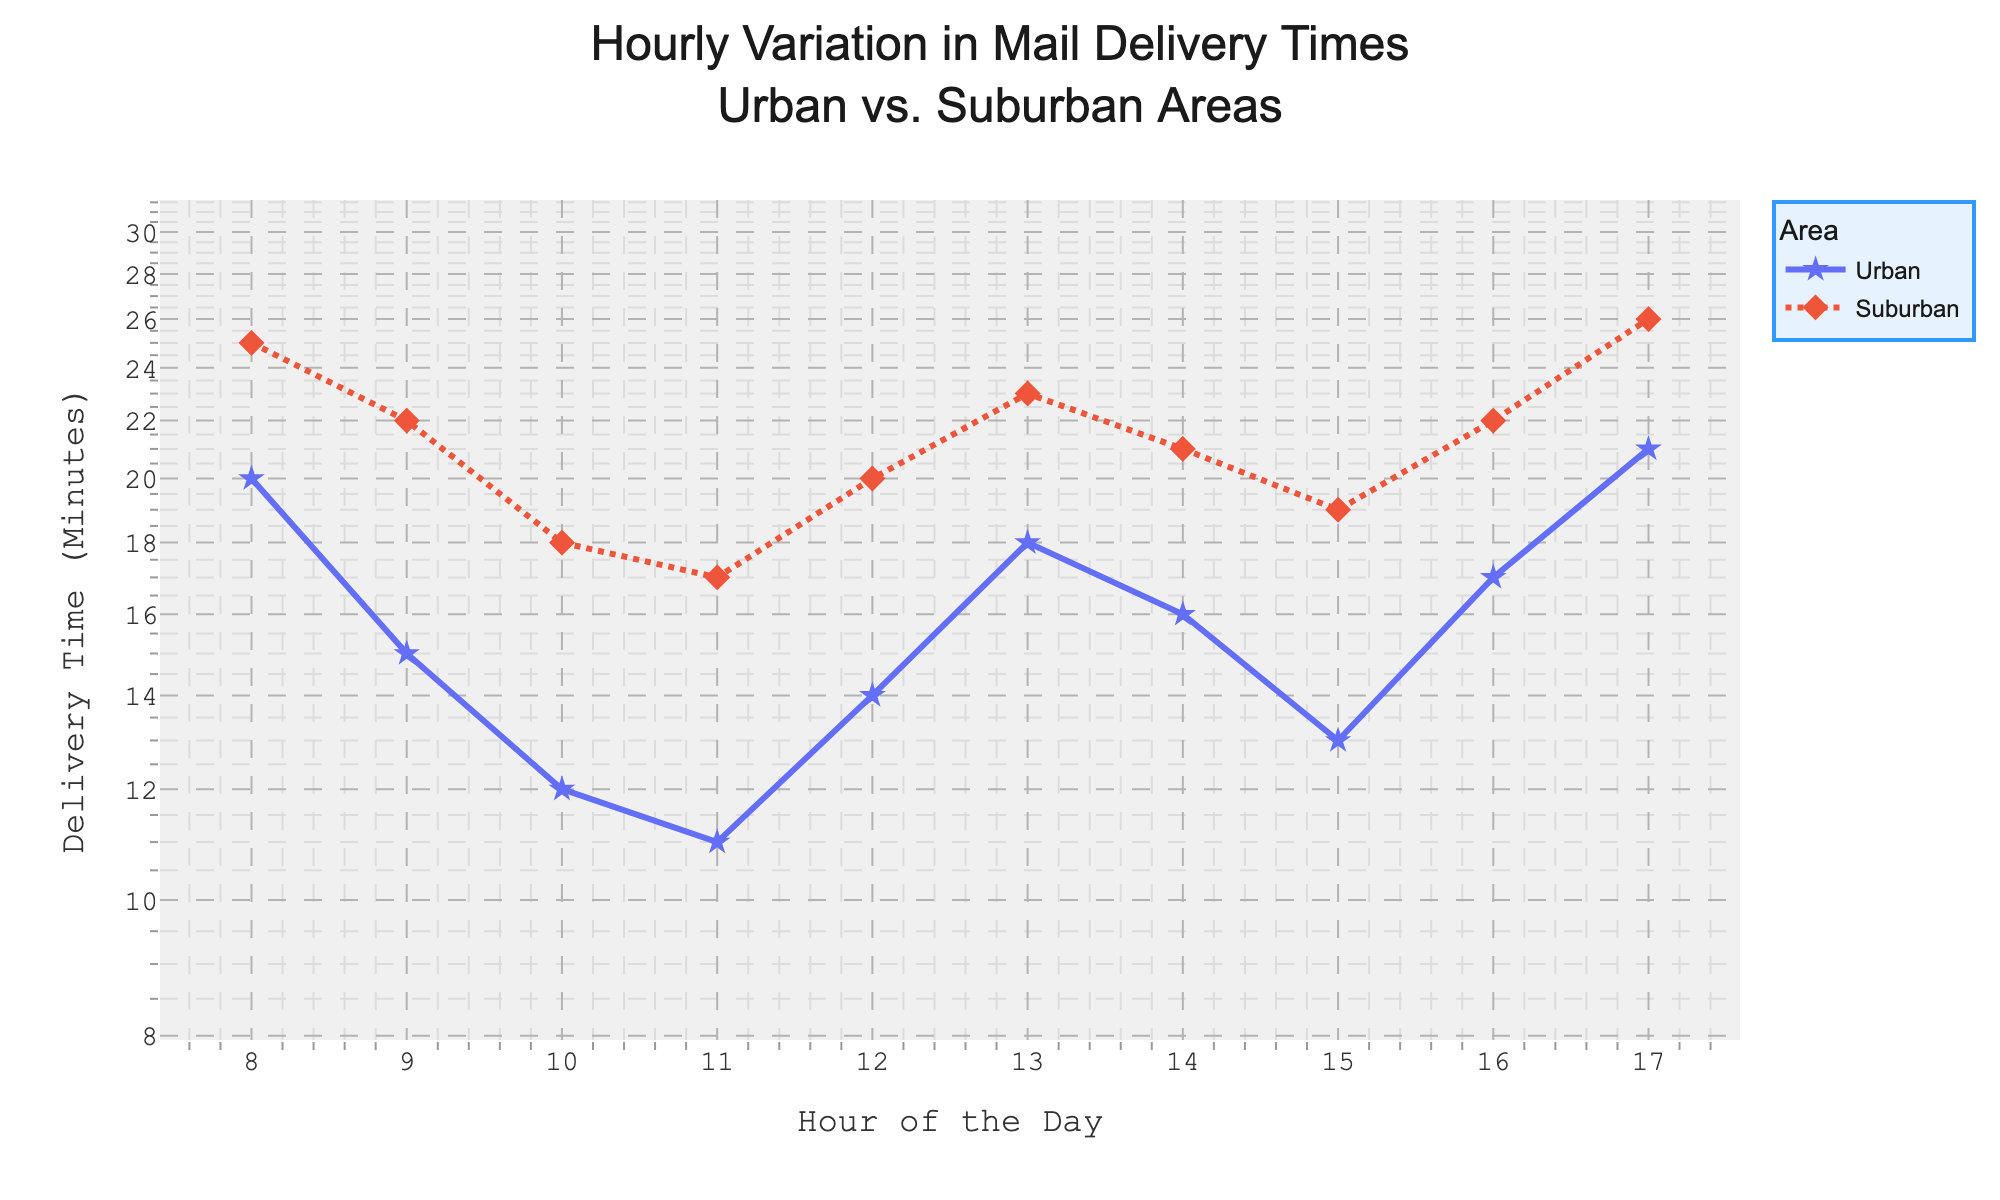What is the title of the plot? Look at the top center of the plot, where the title is usually placed.
Answer: Hourly Variation in Mail Delivery Times Urban vs. Suburban Areas How many different areas are represented in the plot, and what are they? In the legend or the lines on the plot, you can see the different areas represented.
Answer: 2, Urban and Suburban What color represents the Urban area? Check the legend or look at one of the two colored lines in the plot.
Answer: Blue At 10 AM, how long does it take to deliver mail in Suburban areas? Find the '10' on the x-axis, then look at the corresponding point on the line for Suburban areas (dashed line).
Answer: 18 minutes Which area has a higher delivery time at 12 PM? Compare the y-values at 12 PM for both Urban and Suburban areas on the plot.
Answer: Suburban What is the general trend for mail delivery times in both areas as the day progresses? Observe the pattern of the lines as they move from morning to evening.
Answer: Both areas tend to have a lower delivery time in the late morning and higher delivery time in the early morning and late afternoon Calculate the average delivery time at 8 AM for Urban and Suburban areas combined. Add the delivery times for both areas at 8 AM and divide by 2. The times are Urban: 20 minutes, Suburban: 25 minutes. Average = (20 + 25) / 2 = 22.5 minutes.
Answer: 22.5 minutes What hour shows the smallest difference in delivery times between Urban and Suburban areas? Check each hour and find where the difference between the two y-values is the smallest.
Answer: 10 AM By what factor does the delivery time at 8 AM in Suburban areas exceed that in Urban areas? Divide the Suburban delivery time by the Urban delivery time at 8 AM. Factor = 25 minutes / 20 minutes.
Answer: 1.25 Overall, in which area does mail delivery tend to be quicker? Compare the general level of the lines for Urban and Suburban areas through the day.
Answer: Urban 